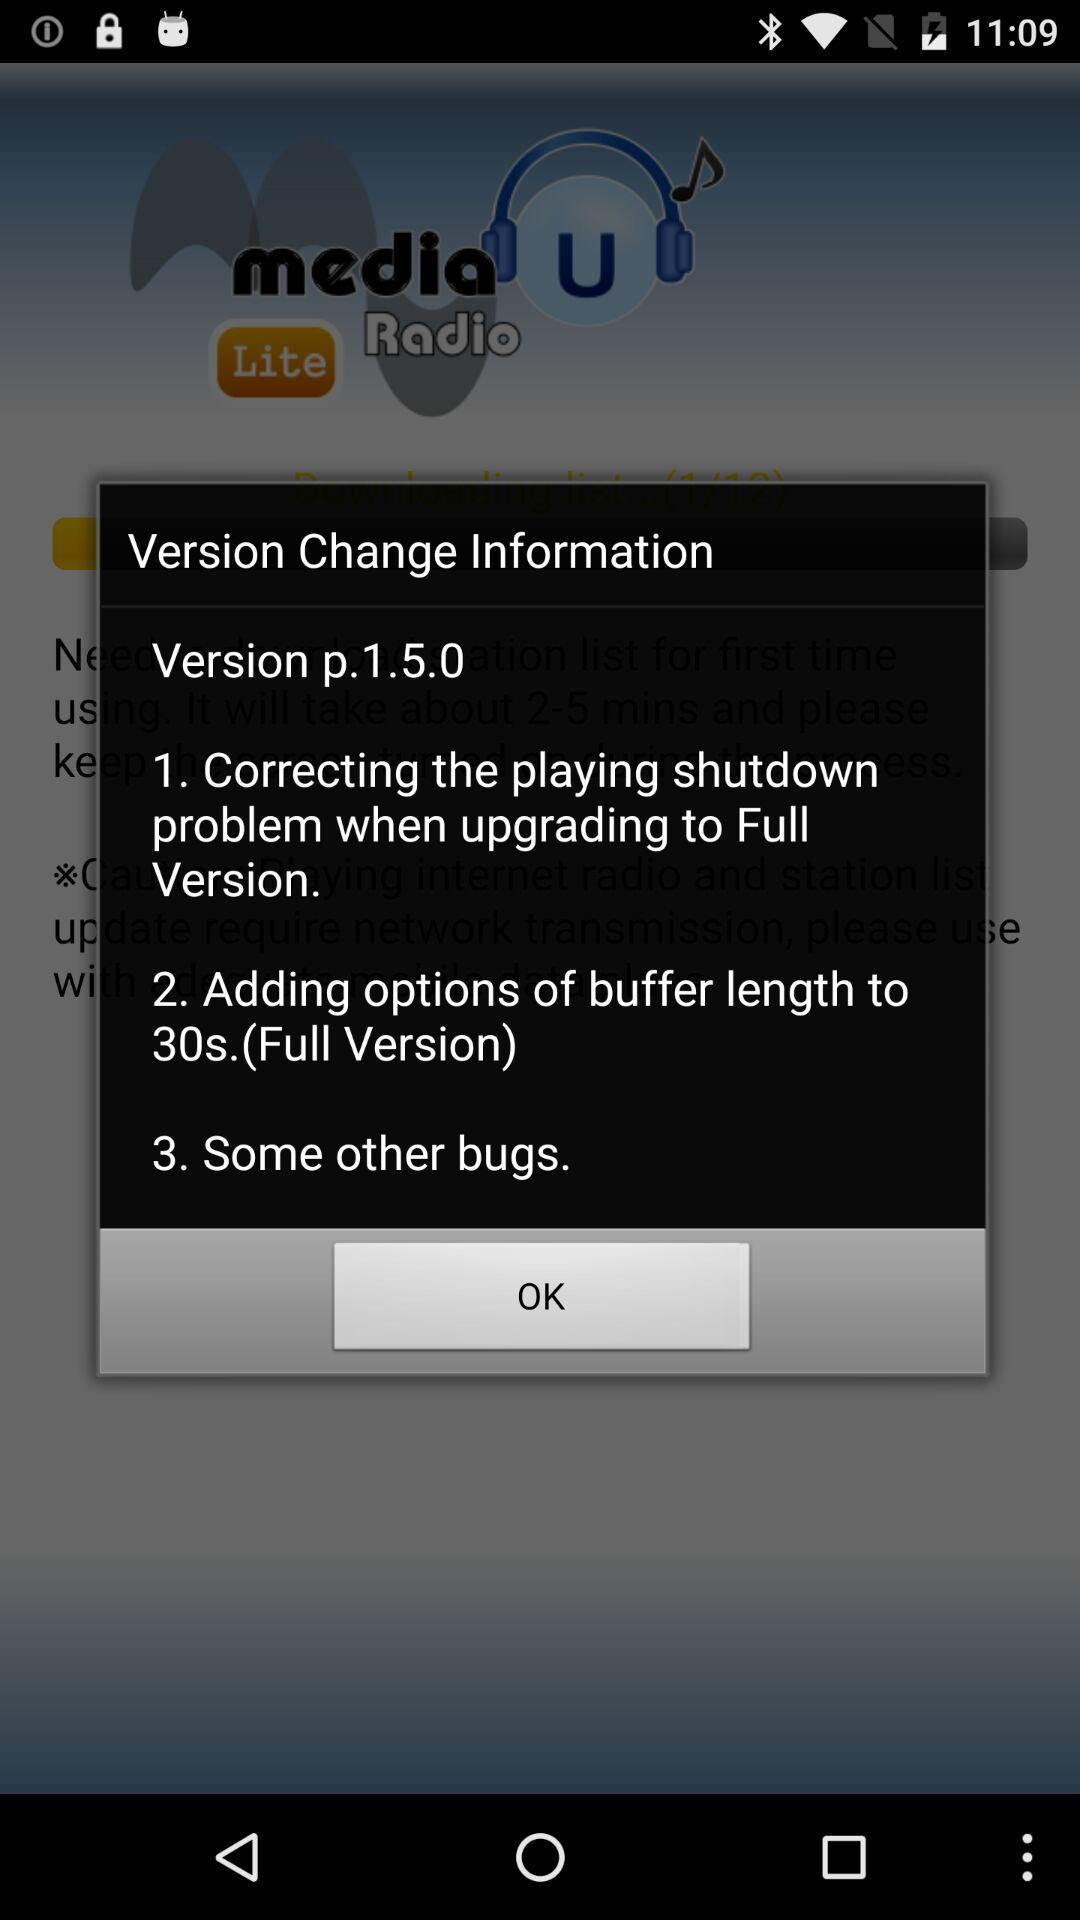What is the name of the application? The name of the application is "media U Radio Lite". 